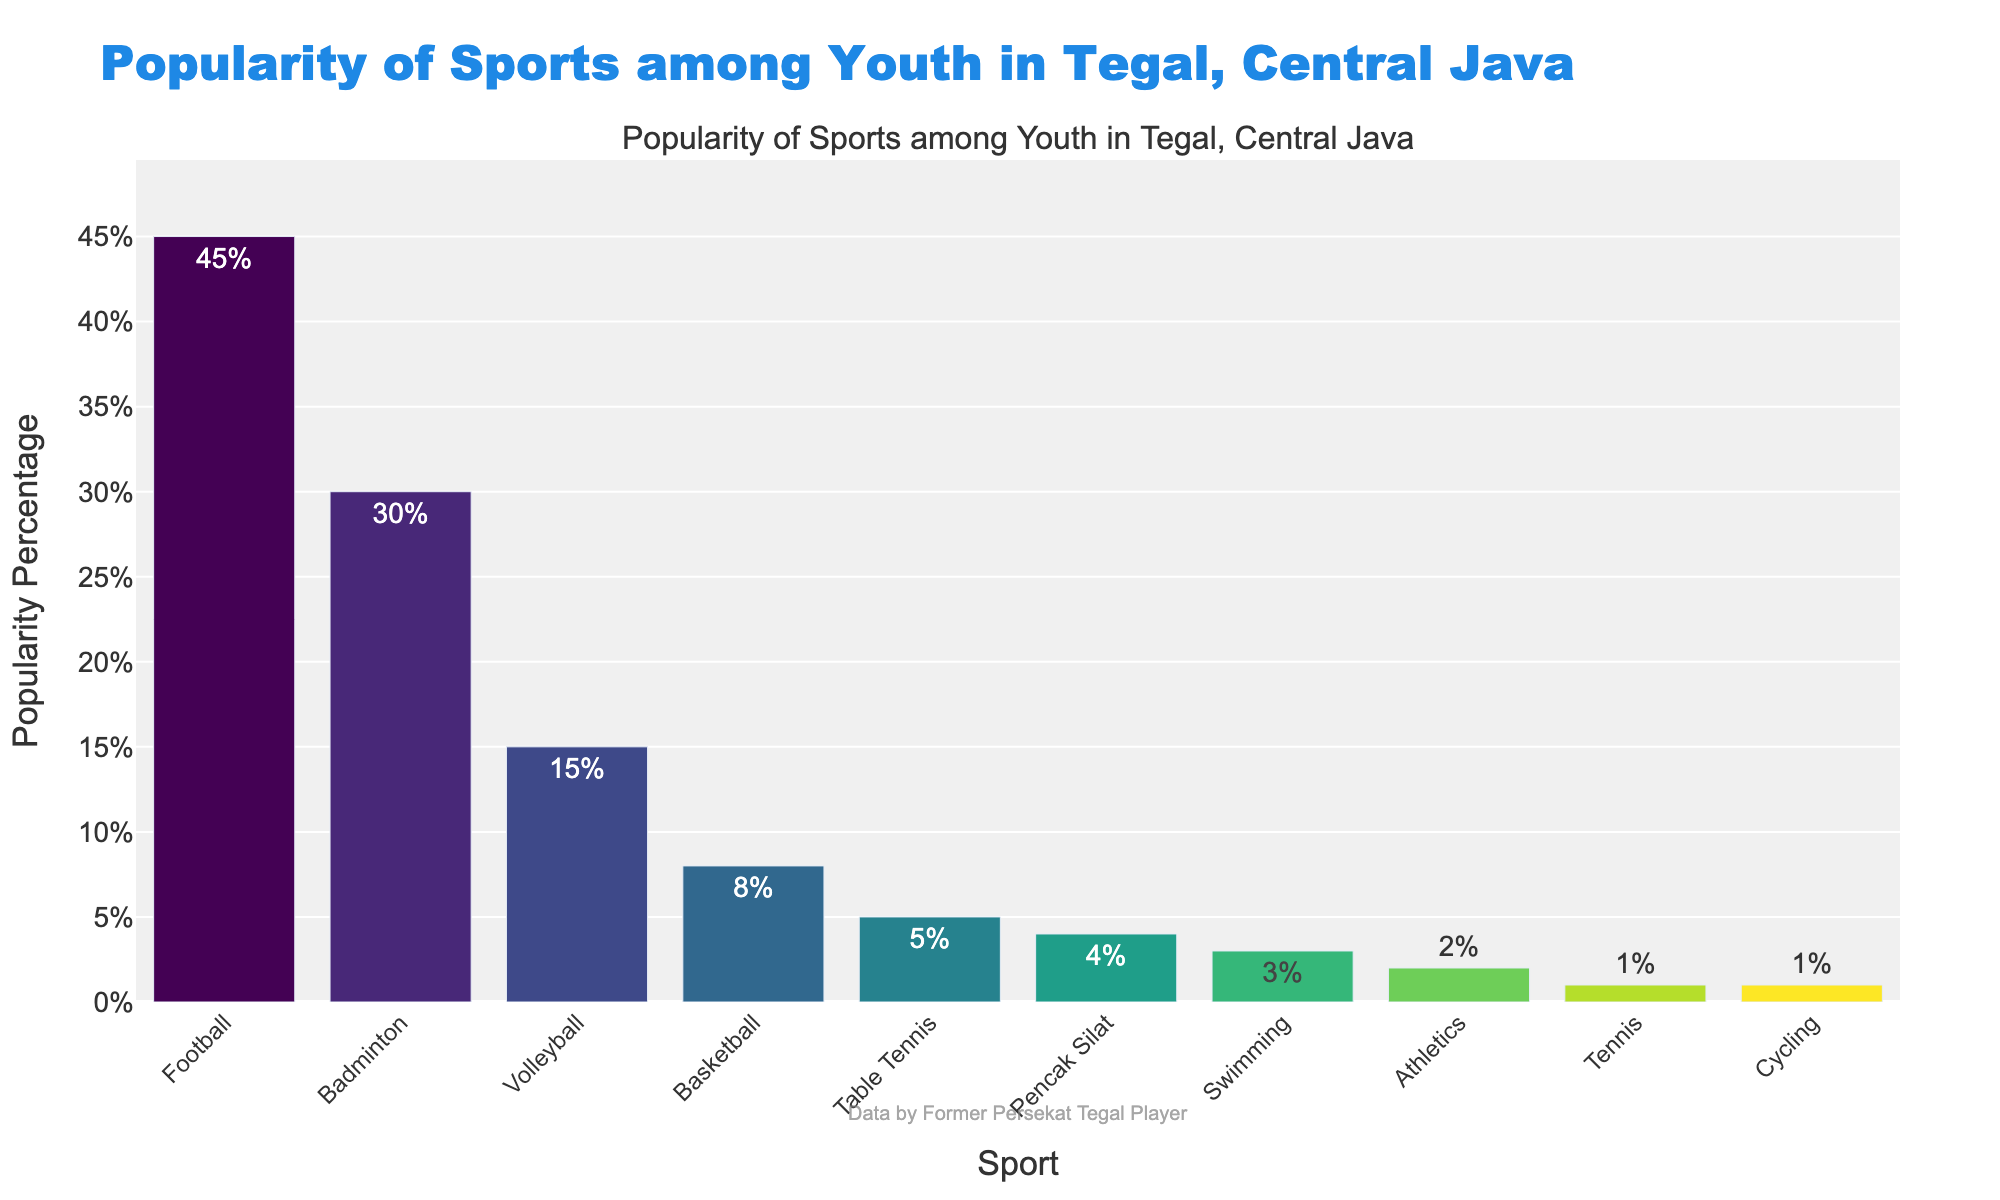What's the most popular sport among youth in Tegal, Central Java? The highest bar in the chart represents Football with a popularity percentage of 45%.
Answer: Football Which sport has the least popularity among the youth in Tegal? The shortest bars in the chart represent Tennis and Cycling, both with a popularity percentage of 1%.
Answer: Tennis and Cycling How much more popular is Football compared to Basketball? Football has a popularity of 45%, and Basketball has 8%. The difference is 45% - 8% = 37%.
Answer: 37% What's the total percentage of popularity for Badminton, Volleyball, and Swimming combined? Adding the popularity percentages for Badminton (30%), Volleyball (15%), and Swimming (3%): 30% + 15% + 3% = 48%.
Answer: 48% Which sports have a popularity percentage of less than 5%? The bars with percentages less than 5% represent Pencak Silat (4%), Swimming (3%), Athletics (2%), Tennis (1%), and Cycling (1%).
Answer: Pencak Silat, Swimming, Athletics, Tennis, and Cycling By how much does Volleyball surpass Swimming in popularity? Volleyball has a popularity of 15%, and Swimming has 3%. The difference is 15% - 3% = 12%.
Answer: 12% Which sport is more popular, Table Tennis or Pencak Silat? The bar for Table Tennis shows 5%, while Pencak Silat shows 4%, indicating Table Tennis is more popular.
Answer: Table Tennis What is the median popularity percentage of all the sports? Arrange the percentages in ascending order: 1%, 1%, 2%, 3%, 4%, 5%, 8%, 15%, 30%, 45%. The median of these sorted values is the average of the 5th and 6th values: (4% + 5%) / 2 = 4.5%.
Answer: 4.5% Which has a greater popularity, the sum of Volleyball and Swimming, or Basketball alone? Volleyball and Swimming combined have: 15% + 3% = 18%. Basketball alone has 8%, so 18% > 8%.
Answer: Volleyball and Swimming combined How many sports have a popularity higher than 10%? The bars representing Football (45%), Badminton (30%), and Volleyball (15%) show popularity percentages higher than 10%. This totals to 3 sports.
Answer: 3 sports 